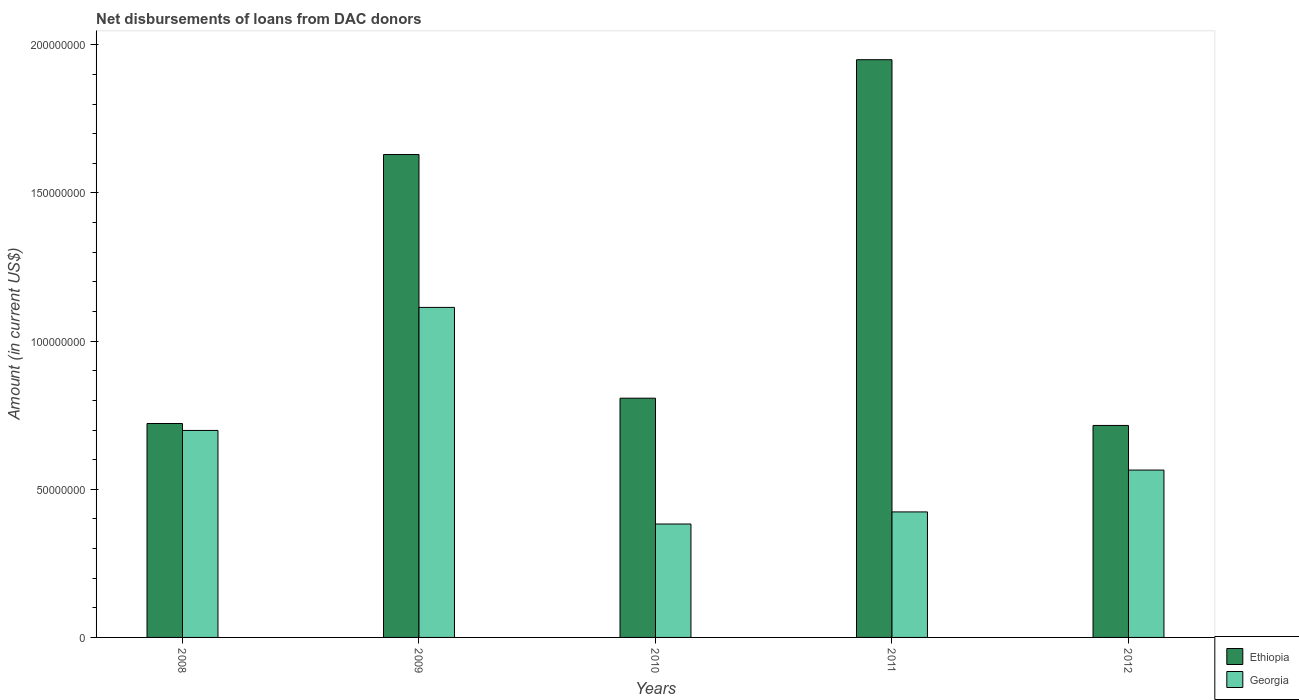How many different coloured bars are there?
Provide a short and direct response. 2. How many groups of bars are there?
Ensure brevity in your answer.  5. How many bars are there on the 5th tick from the right?
Give a very brief answer. 2. What is the label of the 2nd group of bars from the left?
Your response must be concise. 2009. In how many cases, is the number of bars for a given year not equal to the number of legend labels?
Offer a terse response. 0. What is the amount of loans disbursed in Georgia in 2011?
Make the answer very short. 4.24e+07. Across all years, what is the maximum amount of loans disbursed in Georgia?
Your response must be concise. 1.11e+08. Across all years, what is the minimum amount of loans disbursed in Georgia?
Ensure brevity in your answer.  3.83e+07. In which year was the amount of loans disbursed in Ethiopia maximum?
Ensure brevity in your answer.  2011. In which year was the amount of loans disbursed in Ethiopia minimum?
Provide a short and direct response. 2012. What is the total amount of loans disbursed in Georgia in the graph?
Keep it short and to the point. 3.18e+08. What is the difference between the amount of loans disbursed in Ethiopia in 2009 and that in 2011?
Offer a very short reply. -3.20e+07. What is the difference between the amount of loans disbursed in Ethiopia in 2011 and the amount of loans disbursed in Georgia in 2008?
Provide a succinct answer. 1.25e+08. What is the average amount of loans disbursed in Georgia per year?
Offer a terse response. 6.37e+07. In the year 2010, what is the difference between the amount of loans disbursed in Georgia and amount of loans disbursed in Ethiopia?
Your answer should be very brief. -4.25e+07. What is the ratio of the amount of loans disbursed in Georgia in 2010 to that in 2012?
Your answer should be compact. 0.68. Is the difference between the amount of loans disbursed in Georgia in 2008 and 2011 greater than the difference between the amount of loans disbursed in Ethiopia in 2008 and 2011?
Provide a succinct answer. Yes. What is the difference between the highest and the second highest amount of loans disbursed in Ethiopia?
Keep it short and to the point. 3.20e+07. What is the difference between the highest and the lowest amount of loans disbursed in Ethiopia?
Give a very brief answer. 1.23e+08. What does the 2nd bar from the left in 2010 represents?
Provide a succinct answer. Georgia. What does the 2nd bar from the right in 2008 represents?
Provide a succinct answer. Ethiopia. Are the values on the major ticks of Y-axis written in scientific E-notation?
Provide a short and direct response. No. Does the graph contain grids?
Provide a succinct answer. No. What is the title of the graph?
Ensure brevity in your answer.  Net disbursements of loans from DAC donors. What is the label or title of the X-axis?
Keep it short and to the point. Years. What is the Amount (in current US$) of Ethiopia in 2008?
Offer a terse response. 7.22e+07. What is the Amount (in current US$) of Georgia in 2008?
Provide a short and direct response. 6.99e+07. What is the Amount (in current US$) of Ethiopia in 2009?
Your answer should be compact. 1.63e+08. What is the Amount (in current US$) in Georgia in 2009?
Ensure brevity in your answer.  1.11e+08. What is the Amount (in current US$) in Ethiopia in 2010?
Offer a terse response. 8.08e+07. What is the Amount (in current US$) in Georgia in 2010?
Your response must be concise. 3.83e+07. What is the Amount (in current US$) of Ethiopia in 2011?
Offer a very short reply. 1.95e+08. What is the Amount (in current US$) in Georgia in 2011?
Ensure brevity in your answer.  4.24e+07. What is the Amount (in current US$) of Ethiopia in 2012?
Provide a succinct answer. 7.15e+07. What is the Amount (in current US$) of Georgia in 2012?
Your answer should be compact. 5.65e+07. Across all years, what is the maximum Amount (in current US$) in Ethiopia?
Offer a very short reply. 1.95e+08. Across all years, what is the maximum Amount (in current US$) in Georgia?
Your response must be concise. 1.11e+08. Across all years, what is the minimum Amount (in current US$) in Ethiopia?
Your answer should be compact. 7.15e+07. Across all years, what is the minimum Amount (in current US$) in Georgia?
Your answer should be very brief. 3.83e+07. What is the total Amount (in current US$) of Ethiopia in the graph?
Give a very brief answer. 5.82e+08. What is the total Amount (in current US$) of Georgia in the graph?
Give a very brief answer. 3.18e+08. What is the difference between the Amount (in current US$) of Ethiopia in 2008 and that in 2009?
Your response must be concise. -9.08e+07. What is the difference between the Amount (in current US$) of Georgia in 2008 and that in 2009?
Your answer should be compact. -4.15e+07. What is the difference between the Amount (in current US$) in Ethiopia in 2008 and that in 2010?
Your response must be concise. -8.55e+06. What is the difference between the Amount (in current US$) of Georgia in 2008 and that in 2010?
Offer a terse response. 3.16e+07. What is the difference between the Amount (in current US$) in Ethiopia in 2008 and that in 2011?
Provide a short and direct response. -1.23e+08. What is the difference between the Amount (in current US$) in Georgia in 2008 and that in 2011?
Offer a very short reply. 2.75e+07. What is the difference between the Amount (in current US$) of Ethiopia in 2008 and that in 2012?
Your answer should be very brief. 6.56e+05. What is the difference between the Amount (in current US$) in Georgia in 2008 and that in 2012?
Make the answer very short. 1.34e+07. What is the difference between the Amount (in current US$) of Ethiopia in 2009 and that in 2010?
Offer a terse response. 8.22e+07. What is the difference between the Amount (in current US$) of Georgia in 2009 and that in 2010?
Give a very brief answer. 7.31e+07. What is the difference between the Amount (in current US$) in Ethiopia in 2009 and that in 2011?
Provide a short and direct response. -3.20e+07. What is the difference between the Amount (in current US$) in Georgia in 2009 and that in 2011?
Offer a terse response. 6.90e+07. What is the difference between the Amount (in current US$) of Ethiopia in 2009 and that in 2012?
Your answer should be compact. 9.14e+07. What is the difference between the Amount (in current US$) of Georgia in 2009 and that in 2012?
Ensure brevity in your answer.  5.49e+07. What is the difference between the Amount (in current US$) in Ethiopia in 2010 and that in 2011?
Provide a succinct answer. -1.14e+08. What is the difference between the Amount (in current US$) in Georgia in 2010 and that in 2011?
Ensure brevity in your answer.  -4.08e+06. What is the difference between the Amount (in current US$) of Ethiopia in 2010 and that in 2012?
Provide a short and direct response. 9.20e+06. What is the difference between the Amount (in current US$) in Georgia in 2010 and that in 2012?
Your answer should be very brief. -1.82e+07. What is the difference between the Amount (in current US$) in Ethiopia in 2011 and that in 2012?
Give a very brief answer. 1.23e+08. What is the difference between the Amount (in current US$) in Georgia in 2011 and that in 2012?
Offer a terse response. -1.41e+07. What is the difference between the Amount (in current US$) in Ethiopia in 2008 and the Amount (in current US$) in Georgia in 2009?
Give a very brief answer. -3.92e+07. What is the difference between the Amount (in current US$) of Ethiopia in 2008 and the Amount (in current US$) of Georgia in 2010?
Provide a succinct answer. 3.39e+07. What is the difference between the Amount (in current US$) in Ethiopia in 2008 and the Amount (in current US$) in Georgia in 2011?
Keep it short and to the point. 2.98e+07. What is the difference between the Amount (in current US$) in Ethiopia in 2008 and the Amount (in current US$) in Georgia in 2012?
Offer a very short reply. 1.57e+07. What is the difference between the Amount (in current US$) in Ethiopia in 2009 and the Amount (in current US$) in Georgia in 2010?
Provide a succinct answer. 1.25e+08. What is the difference between the Amount (in current US$) of Ethiopia in 2009 and the Amount (in current US$) of Georgia in 2011?
Your answer should be compact. 1.21e+08. What is the difference between the Amount (in current US$) in Ethiopia in 2009 and the Amount (in current US$) in Georgia in 2012?
Give a very brief answer. 1.06e+08. What is the difference between the Amount (in current US$) of Ethiopia in 2010 and the Amount (in current US$) of Georgia in 2011?
Your response must be concise. 3.84e+07. What is the difference between the Amount (in current US$) in Ethiopia in 2010 and the Amount (in current US$) in Georgia in 2012?
Make the answer very short. 2.43e+07. What is the difference between the Amount (in current US$) of Ethiopia in 2011 and the Amount (in current US$) of Georgia in 2012?
Provide a succinct answer. 1.38e+08. What is the average Amount (in current US$) in Ethiopia per year?
Provide a succinct answer. 1.16e+08. What is the average Amount (in current US$) of Georgia per year?
Offer a terse response. 6.37e+07. In the year 2008, what is the difference between the Amount (in current US$) of Ethiopia and Amount (in current US$) of Georgia?
Keep it short and to the point. 2.35e+06. In the year 2009, what is the difference between the Amount (in current US$) of Ethiopia and Amount (in current US$) of Georgia?
Keep it short and to the point. 5.16e+07. In the year 2010, what is the difference between the Amount (in current US$) of Ethiopia and Amount (in current US$) of Georgia?
Ensure brevity in your answer.  4.25e+07. In the year 2011, what is the difference between the Amount (in current US$) in Ethiopia and Amount (in current US$) in Georgia?
Your answer should be very brief. 1.53e+08. In the year 2012, what is the difference between the Amount (in current US$) of Ethiopia and Amount (in current US$) of Georgia?
Give a very brief answer. 1.51e+07. What is the ratio of the Amount (in current US$) in Ethiopia in 2008 to that in 2009?
Provide a short and direct response. 0.44. What is the ratio of the Amount (in current US$) of Georgia in 2008 to that in 2009?
Provide a short and direct response. 0.63. What is the ratio of the Amount (in current US$) in Ethiopia in 2008 to that in 2010?
Offer a terse response. 0.89. What is the ratio of the Amount (in current US$) of Georgia in 2008 to that in 2010?
Make the answer very short. 1.82. What is the ratio of the Amount (in current US$) of Ethiopia in 2008 to that in 2011?
Your answer should be very brief. 0.37. What is the ratio of the Amount (in current US$) of Georgia in 2008 to that in 2011?
Your response must be concise. 1.65. What is the ratio of the Amount (in current US$) in Ethiopia in 2008 to that in 2012?
Provide a short and direct response. 1.01. What is the ratio of the Amount (in current US$) in Georgia in 2008 to that in 2012?
Give a very brief answer. 1.24. What is the ratio of the Amount (in current US$) in Ethiopia in 2009 to that in 2010?
Give a very brief answer. 2.02. What is the ratio of the Amount (in current US$) of Georgia in 2009 to that in 2010?
Offer a terse response. 2.91. What is the ratio of the Amount (in current US$) in Ethiopia in 2009 to that in 2011?
Keep it short and to the point. 0.84. What is the ratio of the Amount (in current US$) in Georgia in 2009 to that in 2011?
Provide a succinct answer. 2.63. What is the ratio of the Amount (in current US$) in Ethiopia in 2009 to that in 2012?
Keep it short and to the point. 2.28. What is the ratio of the Amount (in current US$) of Georgia in 2009 to that in 2012?
Offer a very short reply. 1.97. What is the ratio of the Amount (in current US$) of Ethiopia in 2010 to that in 2011?
Your response must be concise. 0.41. What is the ratio of the Amount (in current US$) in Georgia in 2010 to that in 2011?
Offer a terse response. 0.9. What is the ratio of the Amount (in current US$) of Ethiopia in 2010 to that in 2012?
Your answer should be very brief. 1.13. What is the ratio of the Amount (in current US$) of Georgia in 2010 to that in 2012?
Ensure brevity in your answer.  0.68. What is the ratio of the Amount (in current US$) in Ethiopia in 2011 to that in 2012?
Provide a succinct answer. 2.73. What is the ratio of the Amount (in current US$) of Georgia in 2011 to that in 2012?
Provide a short and direct response. 0.75. What is the difference between the highest and the second highest Amount (in current US$) of Ethiopia?
Provide a short and direct response. 3.20e+07. What is the difference between the highest and the second highest Amount (in current US$) of Georgia?
Provide a succinct answer. 4.15e+07. What is the difference between the highest and the lowest Amount (in current US$) of Ethiopia?
Your answer should be compact. 1.23e+08. What is the difference between the highest and the lowest Amount (in current US$) of Georgia?
Give a very brief answer. 7.31e+07. 